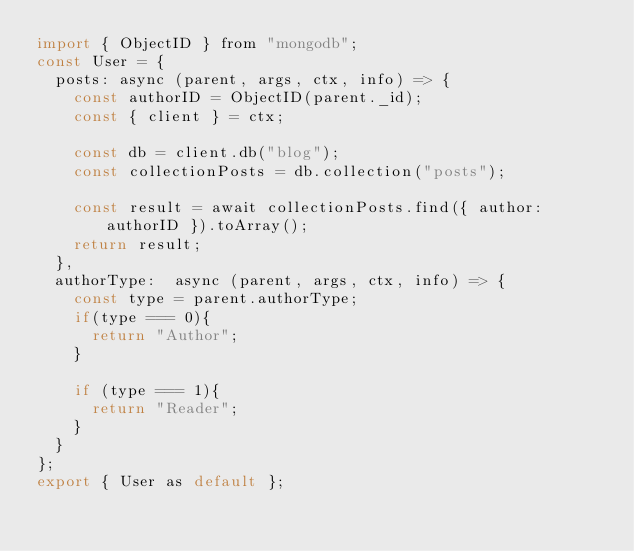<code> <loc_0><loc_0><loc_500><loc_500><_JavaScript_>import { ObjectID } from "mongodb";
const User = {
  posts: async (parent, args, ctx, info) => {
    const authorID = ObjectID(parent._id);
    const { client } = ctx;

    const db = client.db("blog");
    const collectionPosts = db.collection("posts");

    const result = await collectionPosts.find({ author: authorID }).toArray();
    return result;
  },
  authorType:  async (parent, args, ctx, info) => {
    const type = parent.authorType;
    if(type === 0){
      return "Author";
    }

    if (type === 1){
      return "Reader";
    }
  }
};
export { User as default };
</code> 